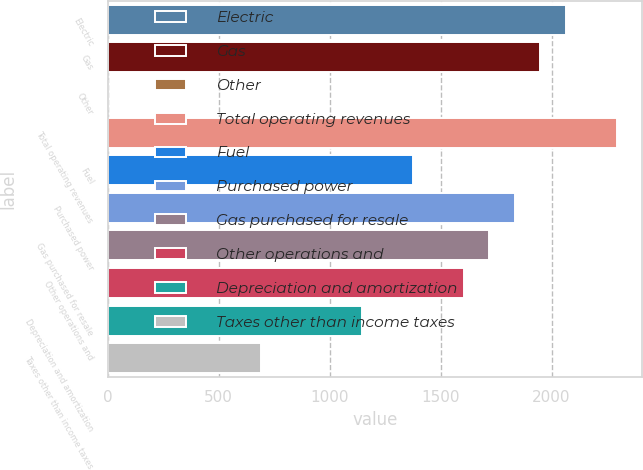Convert chart. <chart><loc_0><loc_0><loc_500><loc_500><bar_chart><fcel>Electric<fcel>Gas<fcel>Other<fcel>Total operating revenues<fcel>Fuel<fcel>Purchased power<fcel>Gas purchased for resale<fcel>Other operations and<fcel>Depreciation and amortization<fcel>Taxes other than income taxes<nl><fcel>2063.8<fcel>1949.2<fcel>1<fcel>2293<fcel>1376.2<fcel>1834.6<fcel>1720<fcel>1605.4<fcel>1147<fcel>688.6<nl></chart> 